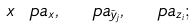Convert formula to latex. <formula><loc_0><loc_0><loc_500><loc_500>x \ p a _ { x } , \ \ p a _ { \tilde { y } _ { j } } , \ \ p a _ { z _ { i } } ;</formula> 